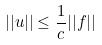Convert formula to latex. <formula><loc_0><loc_0><loc_500><loc_500>| | u | | \leq \frac { 1 } { c } | | f | |</formula> 